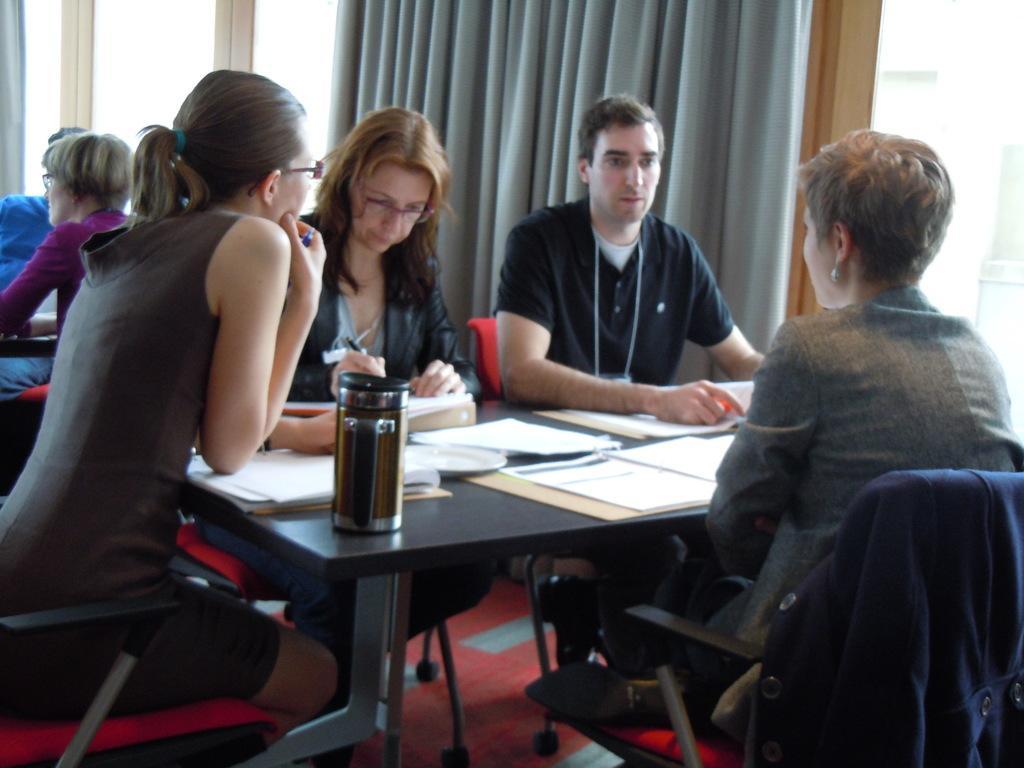How would you summarize this image in a sentence or two? In this picture there are three ladies and one man sitting. To the left side there is a lady sitting. And to the right side there is a lady with grey jacket is sitting. In front of her there is a man with black t-shirt is sitting. Beside her there is a lady with black jacket is sitting. In front of them there is a table with some papers and bottle on it. In the background there are two people sitting and there is a curtain. 